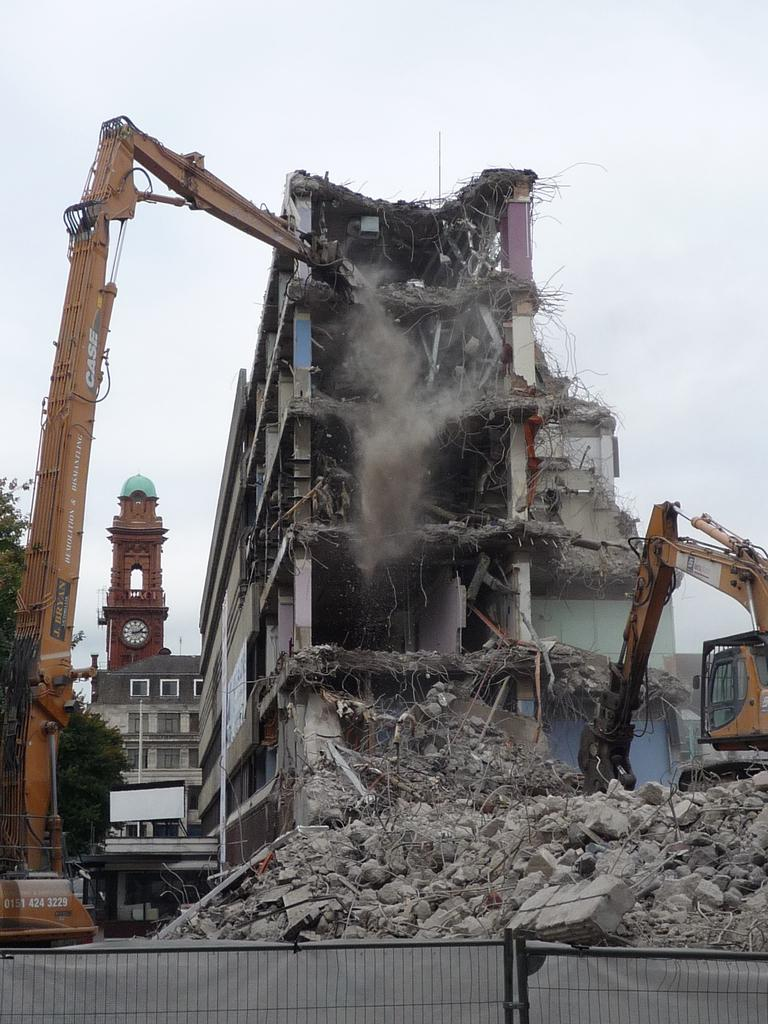What type of structures can be seen in the image? There are buildings in the image. What equipment is present in the image? There are cranes in the image. What type of vegetation is visible in the image? There are trees in the image. What cooking appliances can be seen in the image? There are grills in the image. What type of natural material is present in the image? There are stones in the image. What is visible in the background of the image? The sky is visible in the background of the image. How many giants are holding the watch in the image? There are no giants or watches present in the image. What type of fireman can be seen in the image? There are no firemen present in the image. 